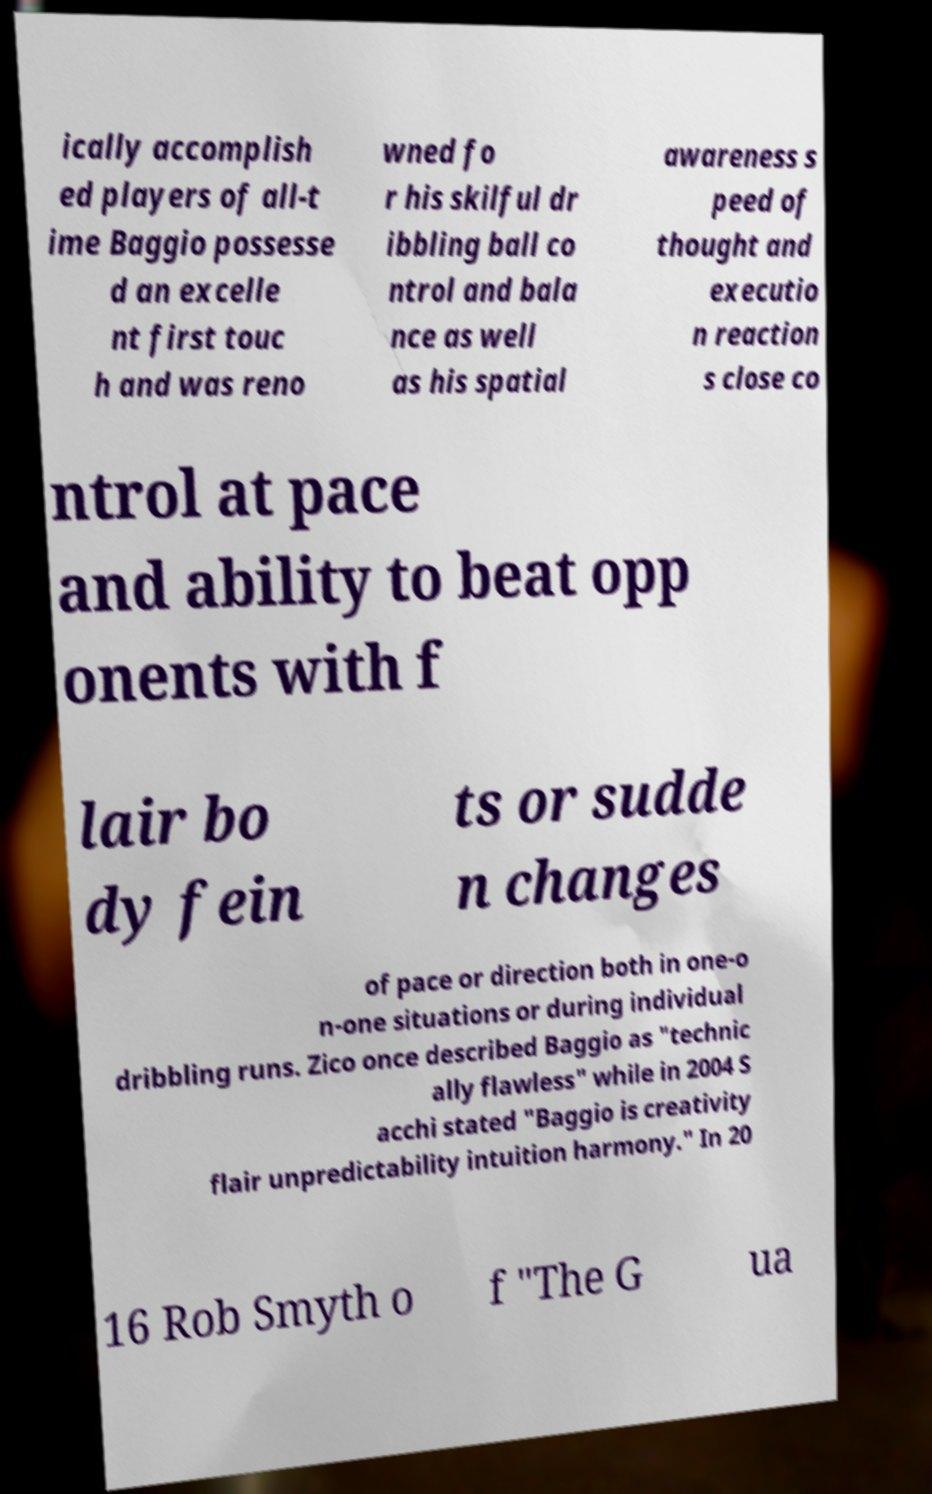Can you accurately transcribe the text from the provided image for me? ically accomplish ed players of all-t ime Baggio possesse d an excelle nt first touc h and was reno wned fo r his skilful dr ibbling ball co ntrol and bala nce as well as his spatial awareness s peed of thought and executio n reaction s close co ntrol at pace and ability to beat opp onents with f lair bo dy fein ts or sudde n changes of pace or direction both in one-o n-one situations or during individual dribbling runs. Zico once described Baggio as "technic ally flawless" while in 2004 S acchi stated "Baggio is creativity flair unpredictability intuition harmony." In 20 16 Rob Smyth o f "The G ua 